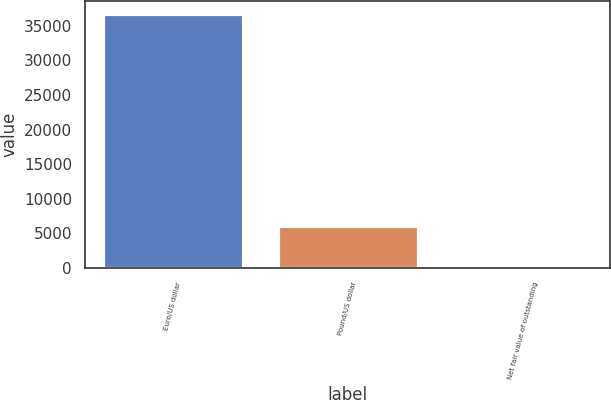Convert chart to OTSL. <chart><loc_0><loc_0><loc_500><loc_500><bar_chart><fcel>Euro/US dollar<fcel>Pound/US dollar<fcel>Net fair value of outstanding<nl><fcel>36684<fcel>6016<fcel>54<nl></chart> 